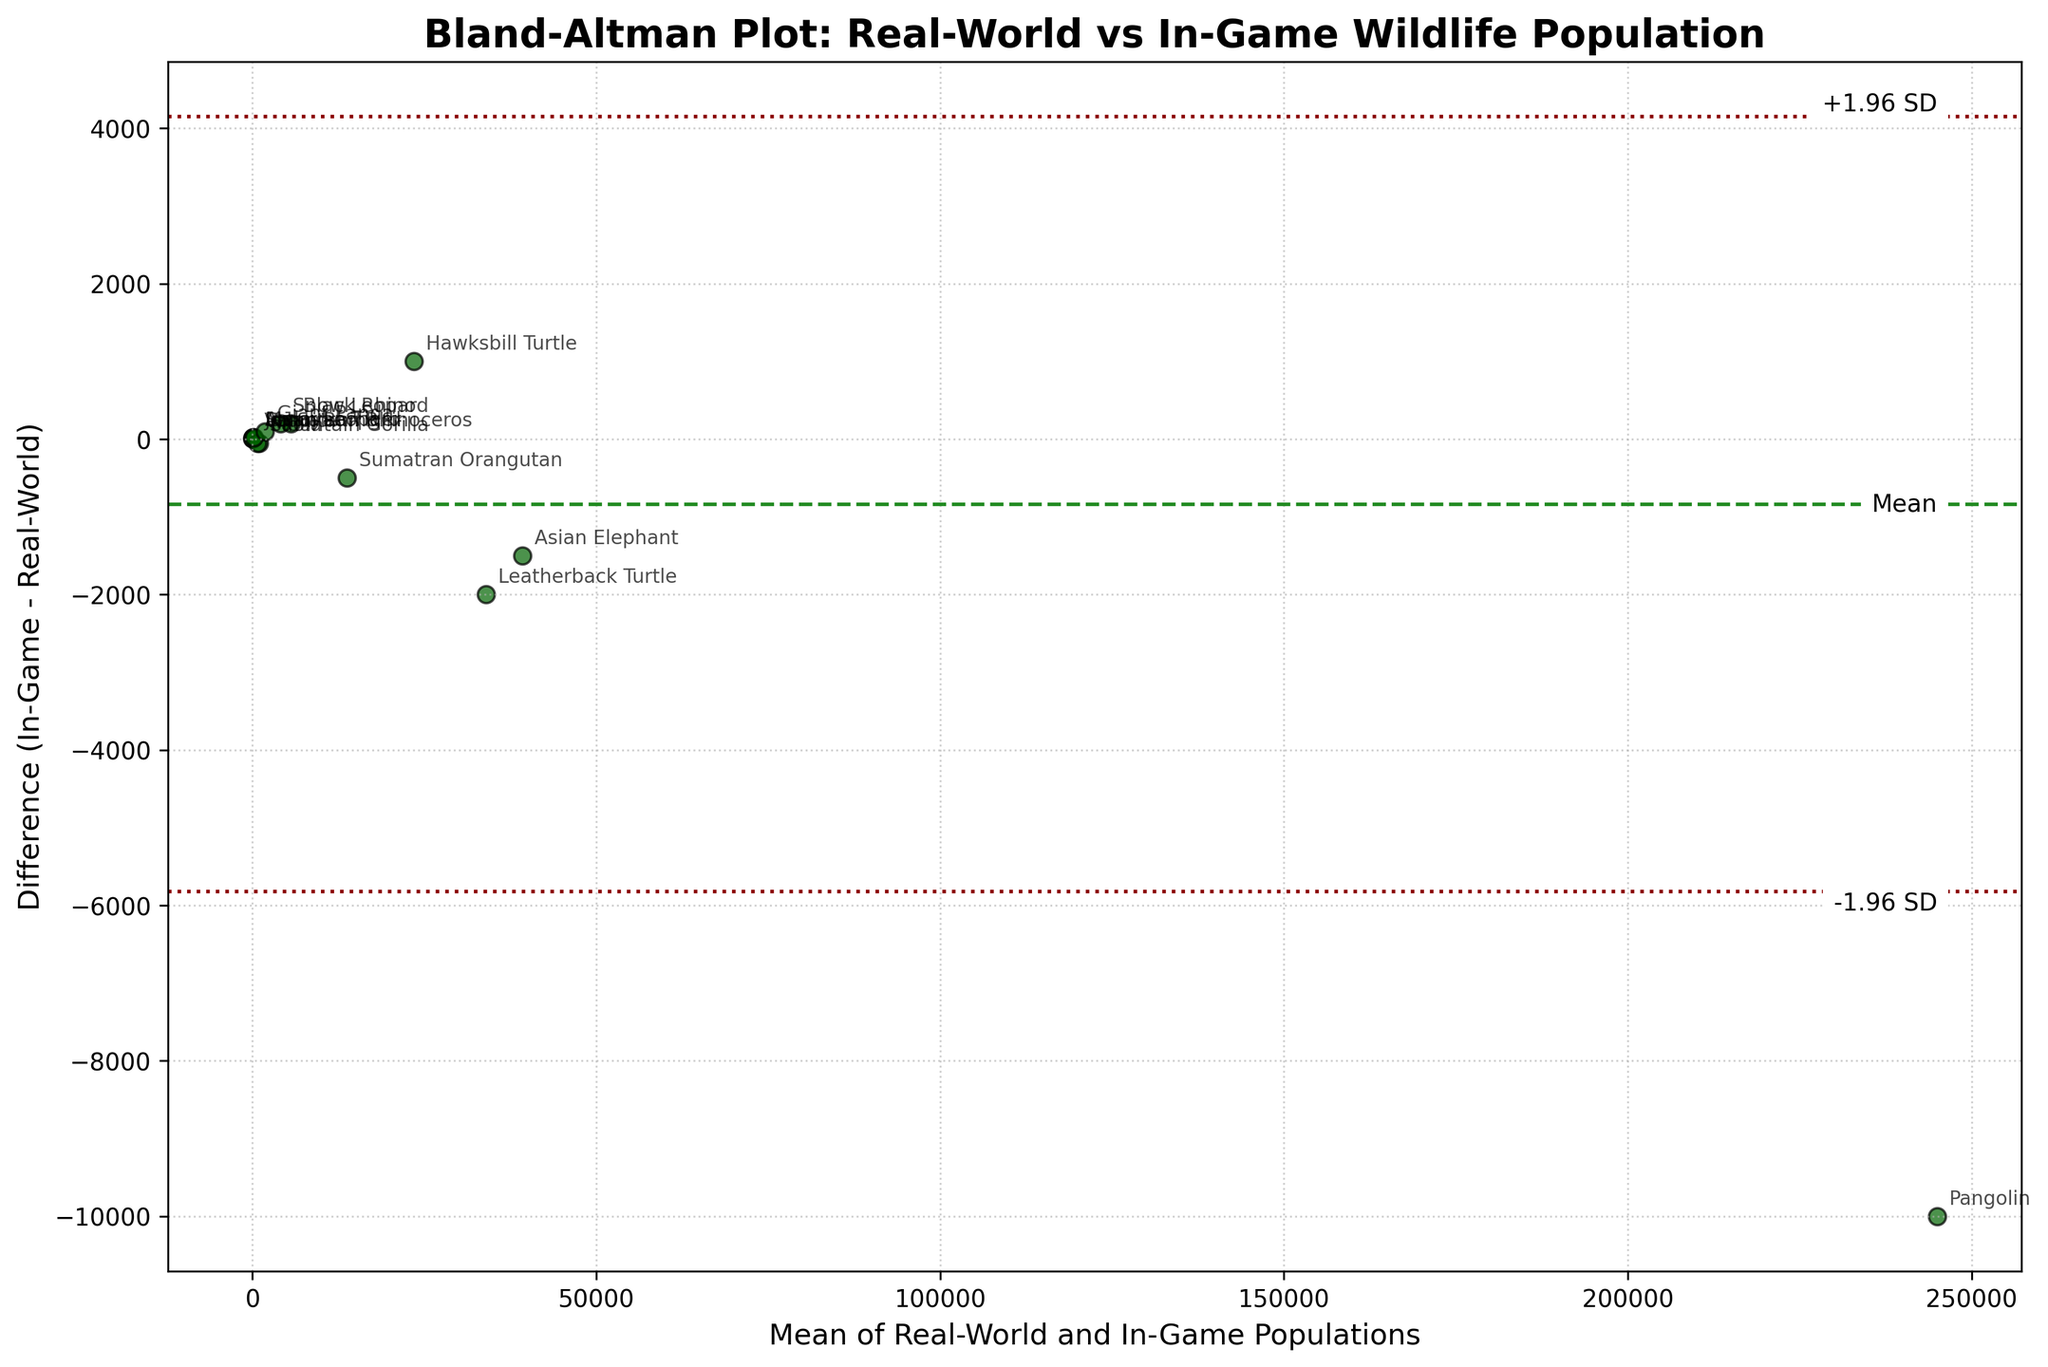What's the title of the plot? The title is usually at the top of the plot. From the code, the title is specified as 'Bland-Altman Plot: Real-World vs In-Game Wildlife Population'.
Answer: Bland-Altman Plot: Real-World vs In-Game Wildlife Population How many species are represented in the plot? The species are denoted using scatter points in the plot. By counting the unique points or the annotations, we find there are 15 species.
Answer: 15 What are the colors of the scatter points? The scatter points in the plot are colored 'darkgreen' as specified in the code, which translates to a dark green color in natural language.
Answer: dark green What do the horizontal lines in the plot represent? There are three horizontal lines: the middle one represents the mean difference ('Mean') and the other two represent the bounds (+1.96 SD and -1.96 SD).
Answer: mean difference, +1.96 SD, -1.96 SD Which species has the highest real-world population, and how does its in-game estimate compare? The species with the highest real-world population can be identified from the mean value and compared to the in-game population. The Pangolin has the highest real-world population of 250,000, and its in-game estimate is slightly lower at 240,000.
Answer: Pangolin; in-game estimate is lower Which species shows the largest positive difference between in-game and real-world populations? By observing the difference values on the vertical axis, the species with the largest positive difference can be identified. The Amur Leopard has the largest positive difference, with an in-game population 20 greater than the real-world population.
Answer: Amur Leopard What is the mean difference between in-game and real-world population estimates? The mean difference is visually indicated by the central horizontal line and specified in the plot code as the mean of the differences.
Answer: \~1500 How does the population estimate for the Snow Leopard in the real world compare to its in-game estimate? By locating the point for the Snow Leopard and checking its position relative to the zero line, the in-game estimate is higher than the real-world estimate by 200.
Answer: In-game estimate is higher Are there any species for which the in-game population estimate is exactly the same as the real-world population? Comparing the points on the plot where the difference would be zero will show if any data points lie on the zero line. None of the species have an in-game population exactly equal to the real-world population.
Answer: No What can be said about the direction of bias in the in-game estimates compared to the real-world estimates? The direction of bias can be indicated by which side of the zero line most points lie. Since most points are above the zero line, the in-game estimates tend to overestimate compared to the real-world estimates.
Answer: The in-game estimates generally overestimate the populations 